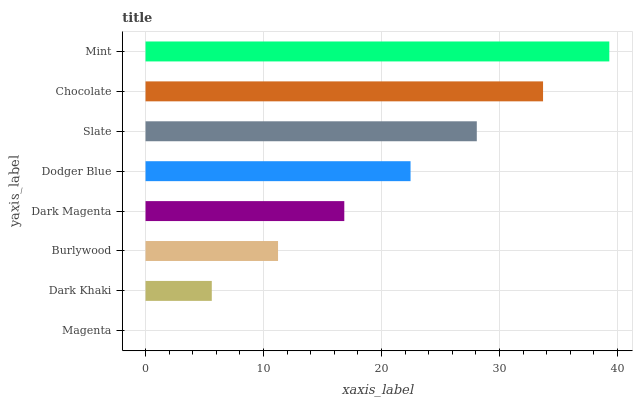Is Magenta the minimum?
Answer yes or no. Yes. Is Mint the maximum?
Answer yes or no. Yes. Is Dark Khaki the minimum?
Answer yes or no. No. Is Dark Khaki the maximum?
Answer yes or no. No. Is Dark Khaki greater than Magenta?
Answer yes or no. Yes. Is Magenta less than Dark Khaki?
Answer yes or no. Yes. Is Magenta greater than Dark Khaki?
Answer yes or no. No. Is Dark Khaki less than Magenta?
Answer yes or no. No. Is Dodger Blue the high median?
Answer yes or no. Yes. Is Dark Magenta the low median?
Answer yes or no. Yes. Is Dark Khaki the high median?
Answer yes or no. No. Is Dodger Blue the low median?
Answer yes or no. No. 